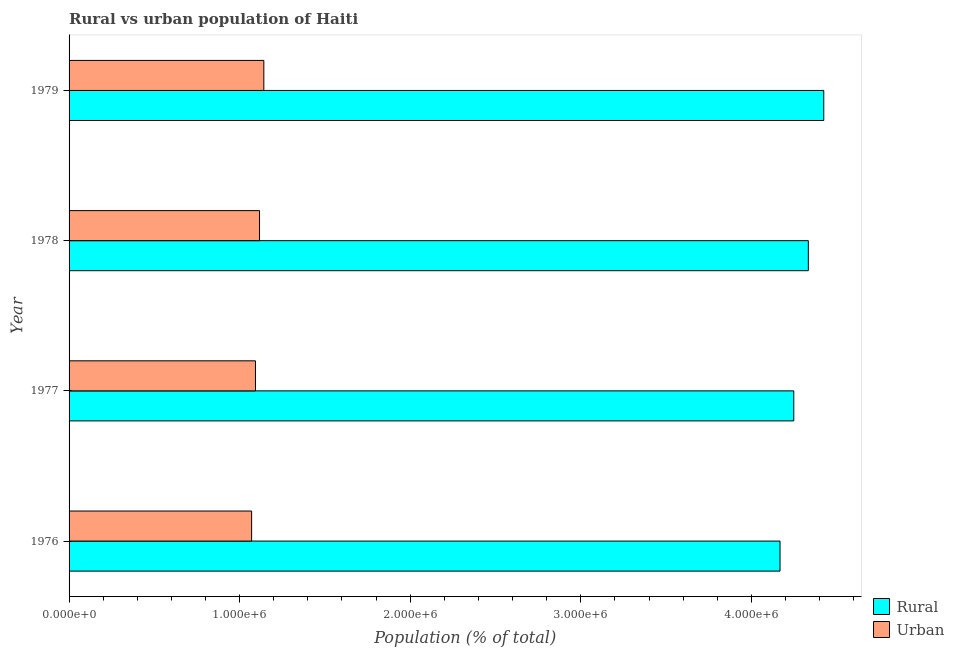How many groups of bars are there?
Give a very brief answer. 4. Are the number of bars on each tick of the Y-axis equal?
Your answer should be compact. Yes. How many bars are there on the 4th tick from the bottom?
Your answer should be compact. 2. What is the label of the 2nd group of bars from the top?
Give a very brief answer. 1978. What is the urban population density in 1979?
Give a very brief answer. 1.14e+06. Across all years, what is the maximum rural population density?
Provide a succinct answer. 4.42e+06. Across all years, what is the minimum urban population density?
Provide a succinct answer. 1.07e+06. In which year was the rural population density maximum?
Provide a succinct answer. 1979. In which year was the rural population density minimum?
Your response must be concise. 1976. What is the total urban population density in the graph?
Provide a succinct answer. 4.42e+06. What is the difference between the rural population density in 1977 and that in 1979?
Give a very brief answer. -1.76e+05. What is the difference between the urban population density in 1976 and the rural population density in 1977?
Make the answer very short. -3.18e+06. What is the average urban population density per year?
Provide a succinct answer. 1.11e+06. In the year 1976, what is the difference between the urban population density and rural population density?
Provide a short and direct response. -3.10e+06. What is the ratio of the urban population density in 1977 to that in 1978?
Offer a very short reply. 0.98. Is the urban population density in 1976 less than that in 1978?
Provide a succinct answer. Yes. Is the difference between the rural population density in 1976 and 1979 greater than the difference between the urban population density in 1976 and 1979?
Your answer should be very brief. No. What is the difference between the highest and the second highest rural population density?
Keep it short and to the point. 9.05e+04. What is the difference between the highest and the lowest urban population density?
Your answer should be compact. 7.16e+04. In how many years, is the rural population density greater than the average rural population density taken over all years?
Give a very brief answer. 2. What does the 2nd bar from the top in 1978 represents?
Keep it short and to the point. Rural. What does the 1st bar from the bottom in 1976 represents?
Make the answer very short. Rural. How many bars are there?
Offer a very short reply. 8. Does the graph contain any zero values?
Keep it short and to the point. No. Where does the legend appear in the graph?
Keep it short and to the point. Bottom right. How many legend labels are there?
Offer a terse response. 2. What is the title of the graph?
Offer a terse response. Rural vs urban population of Haiti. Does "Transport services" appear as one of the legend labels in the graph?
Provide a short and direct response. No. What is the label or title of the X-axis?
Provide a short and direct response. Population (% of total). What is the Population (% of total) of Rural in 1976?
Ensure brevity in your answer.  4.17e+06. What is the Population (% of total) in Urban in 1976?
Your response must be concise. 1.07e+06. What is the Population (% of total) in Rural in 1977?
Ensure brevity in your answer.  4.25e+06. What is the Population (% of total) of Urban in 1977?
Offer a very short reply. 1.09e+06. What is the Population (% of total) of Rural in 1978?
Give a very brief answer. 4.33e+06. What is the Population (% of total) in Urban in 1978?
Provide a succinct answer. 1.12e+06. What is the Population (% of total) of Rural in 1979?
Provide a succinct answer. 4.42e+06. What is the Population (% of total) in Urban in 1979?
Your answer should be very brief. 1.14e+06. Across all years, what is the maximum Population (% of total) of Rural?
Your answer should be very brief. 4.42e+06. Across all years, what is the maximum Population (% of total) in Urban?
Provide a short and direct response. 1.14e+06. Across all years, what is the minimum Population (% of total) in Rural?
Your response must be concise. 4.17e+06. Across all years, what is the minimum Population (% of total) in Urban?
Your response must be concise. 1.07e+06. What is the total Population (% of total) of Rural in the graph?
Make the answer very short. 1.72e+07. What is the total Population (% of total) of Urban in the graph?
Keep it short and to the point. 4.42e+06. What is the difference between the Population (% of total) of Rural in 1976 and that in 1977?
Give a very brief answer. -8.06e+04. What is the difference between the Population (% of total) of Urban in 1976 and that in 1977?
Your answer should be very brief. -2.26e+04. What is the difference between the Population (% of total) of Rural in 1976 and that in 1978?
Your answer should be compact. -1.66e+05. What is the difference between the Population (% of total) of Urban in 1976 and that in 1978?
Offer a very short reply. -4.64e+04. What is the difference between the Population (% of total) in Rural in 1976 and that in 1979?
Your answer should be very brief. -2.56e+05. What is the difference between the Population (% of total) of Urban in 1976 and that in 1979?
Keep it short and to the point. -7.16e+04. What is the difference between the Population (% of total) of Rural in 1977 and that in 1978?
Offer a terse response. -8.53e+04. What is the difference between the Population (% of total) in Urban in 1977 and that in 1978?
Give a very brief answer. -2.38e+04. What is the difference between the Population (% of total) of Rural in 1977 and that in 1979?
Provide a succinct answer. -1.76e+05. What is the difference between the Population (% of total) in Urban in 1977 and that in 1979?
Offer a terse response. -4.90e+04. What is the difference between the Population (% of total) of Rural in 1978 and that in 1979?
Provide a succinct answer. -9.05e+04. What is the difference between the Population (% of total) in Urban in 1978 and that in 1979?
Your answer should be compact. -2.52e+04. What is the difference between the Population (% of total) of Rural in 1976 and the Population (% of total) of Urban in 1977?
Keep it short and to the point. 3.08e+06. What is the difference between the Population (% of total) in Rural in 1976 and the Population (% of total) in Urban in 1978?
Give a very brief answer. 3.05e+06. What is the difference between the Population (% of total) in Rural in 1976 and the Population (% of total) in Urban in 1979?
Provide a short and direct response. 3.03e+06. What is the difference between the Population (% of total) of Rural in 1977 and the Population (% of total) of Urban in 1978?
Provide a short and direct response. 3.13e+06. What is the difference between the Population (% of total) of Rural in 1977 and the Population (% of total) of Urban in 1979?
Give a very brief answer. 3.11e+06. What is the difference between the Population (% of total) of Rural in 1978 and the Population (% of total) of Urban in 1979?
Give a very brief answer. 3.19e+06. What is the average Population (% of total) in Rural per year?
Offer a very short reply. 4.29e+06. What is the average Population (% of total) in Urban per year?
Your answer should be compact. 1.11e+06. In the year 1976, what is the difference between the Population (% of total) of Rural and Population (% of total) of Urban?
Your answer should be compact. 3.10e+06. In the year 1977, what is the difference between the Population (% of total) in Rural and Population (% of total) in Urban?
Provide a short and direct response. 3.16e+06. In the year 1978, what is the difference between the Population (% of total) in Rural and Population (% of total) in Urban?
Your response must be concise. 3.22e+06. In the year 1979, what is the difference between the Population (% of total) of Rural and Population (% of total) of Urban?
Your answer should be compact. 3.28e+06. What is the ratio of the Population (% of total) of Urban in 1976 to that in 1977?
Ensure brevity in your answer.  0.98. What is the ratio of the Population (% of total) of Rural in 1976 to that in 1978?
Provide a short and direct response. 0.96. What is the ratio of the Population (% of total) in Urban in 1976 to that in 1978?
Offer a terse response. 0.96. What is the ratio of the Population (% of total) of Rural in 1976 to that in 1979?
Your answer should be very brief. 0.94. What is the ratio of the Population (% of total) of Urban in 1976 to that in 1979?
Offer a terse response. 0.94. What is the ratio of the Population (% of total) in Rural in 1977 to that in 1978?
Offer a very short reply. 0.98. What is the ratio of the Population (% of total) in Urban in 1977 to that in 1978?
Make the answer very short. 0.98. What is the ratio of the Population (% of total) in Rural in 1977 to that in 1979?
Offer a terse response. 0.96. What is the ratio of the Population (% of total) in Urban in 1977 to that in 1979?
Provide a short and direct response. 0.96. What is the ratio of the Population (% of total) in Rural in 1978 to that in 1979?
Your answer should be very brief. 0.98. What is the ratio of the Population (% of total) in Urban in 1978 to that in 1979?
Offer a terse response. 0.98. What is the difference between the highest and the second highest Population (% of total) of Rural?
Offer a terse response. 9.05e+04. What is the difference between the highest and the second highest Population (% of total) in Urban?
Your answer should be very brief. 2.52e+04. What is the difference between the highest and the lowest Population (% of total) of Rural?
Your answer should be very brief. 2.56e+05. What is the difference between the highest and the lowest Population (% of total) in Urban?
Your answer should be compact. 7.16e+04. 